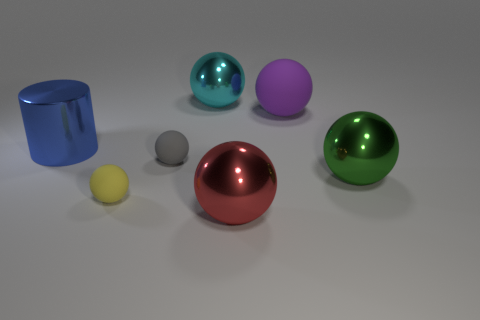There is a shiny thing that is behind the big matte object; is its shape the same as the small gray object that is behind the big green shiny sphere?
Provide a short and direct response. Yes. Are there more big spheres in front of the large cyan object than cyan rubber spheres?
Offer a very short reply. Yes. How many things are large purple metal cubes or gray matte balls?
Make the answer very short. 1. The metal cylinder is what color?
Provide a succinct answer. Blue. What number of other objects are the same color as the large matte ball?
Provide a succinct answer. 0. There is a red object; are there any big cyan shiny spheres in front of it?
Your response must be concise. No. The big metallic thing that is behind the matte ball that is to the right of the large object behind the purple object is what color?
Your answer should be compact. Cyan. How many rubber spheres are both to the right of the yellow rubber sphere and in front of the big blue metal cylinder?
Your answer should be compact. 1. How many balls are either small yellow rubber objects or blue shiny objects?
Give a very brief answer. 1. Are there any metal spheres?
Your response must be concise. Yes. 